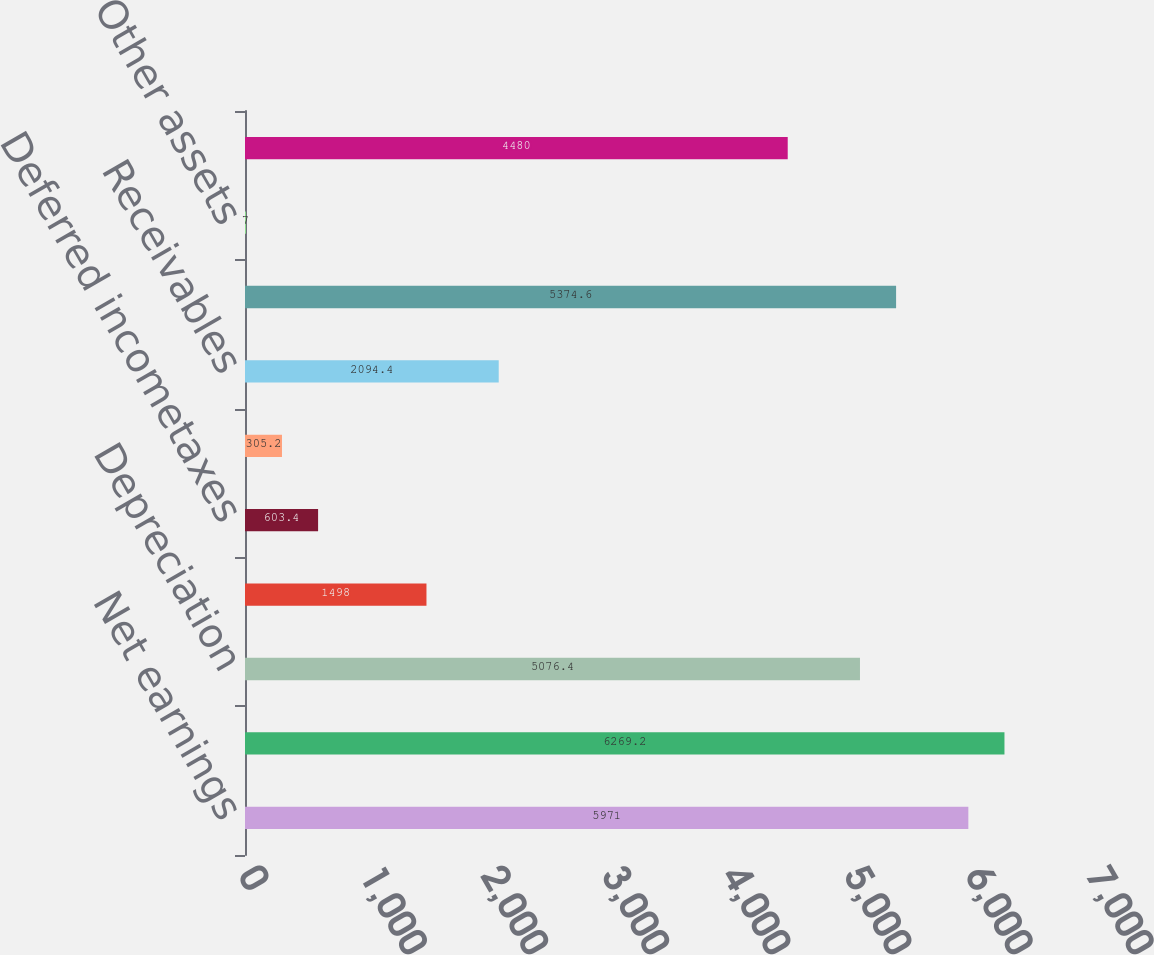Convert chart to OTSL. <chart><loc_0><loc_0><loc_500><loc_500><bar_chart><fcel>Net earnings<fcel>Earnings from continuing<fcel>Depreciation<fcel>Asset impairment charges<fcel>Deferred incometaxes<fcel>Other net<fcel>Receivables<fcel>Merchandise inventories<fcel>Other assets<fcel>Accounts payable<nl><fcel>5971<fcel>6269.2<fcel>5076.4<fcel>1498<fcel>603.4<fcel>305.2<fcel>2094.4<fcel>5374.6<fcel>7<fcel>4480<nl></chart> 